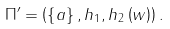Convert formula to latex. <formula><loc_0><loc_0><loc_500><loc_500>\Pi ^ { \prime } = \left ( \left \{ a \right \} , h _ { 1 } , h _ { 2 } \left ( w \right ) \right ) .</formula> 